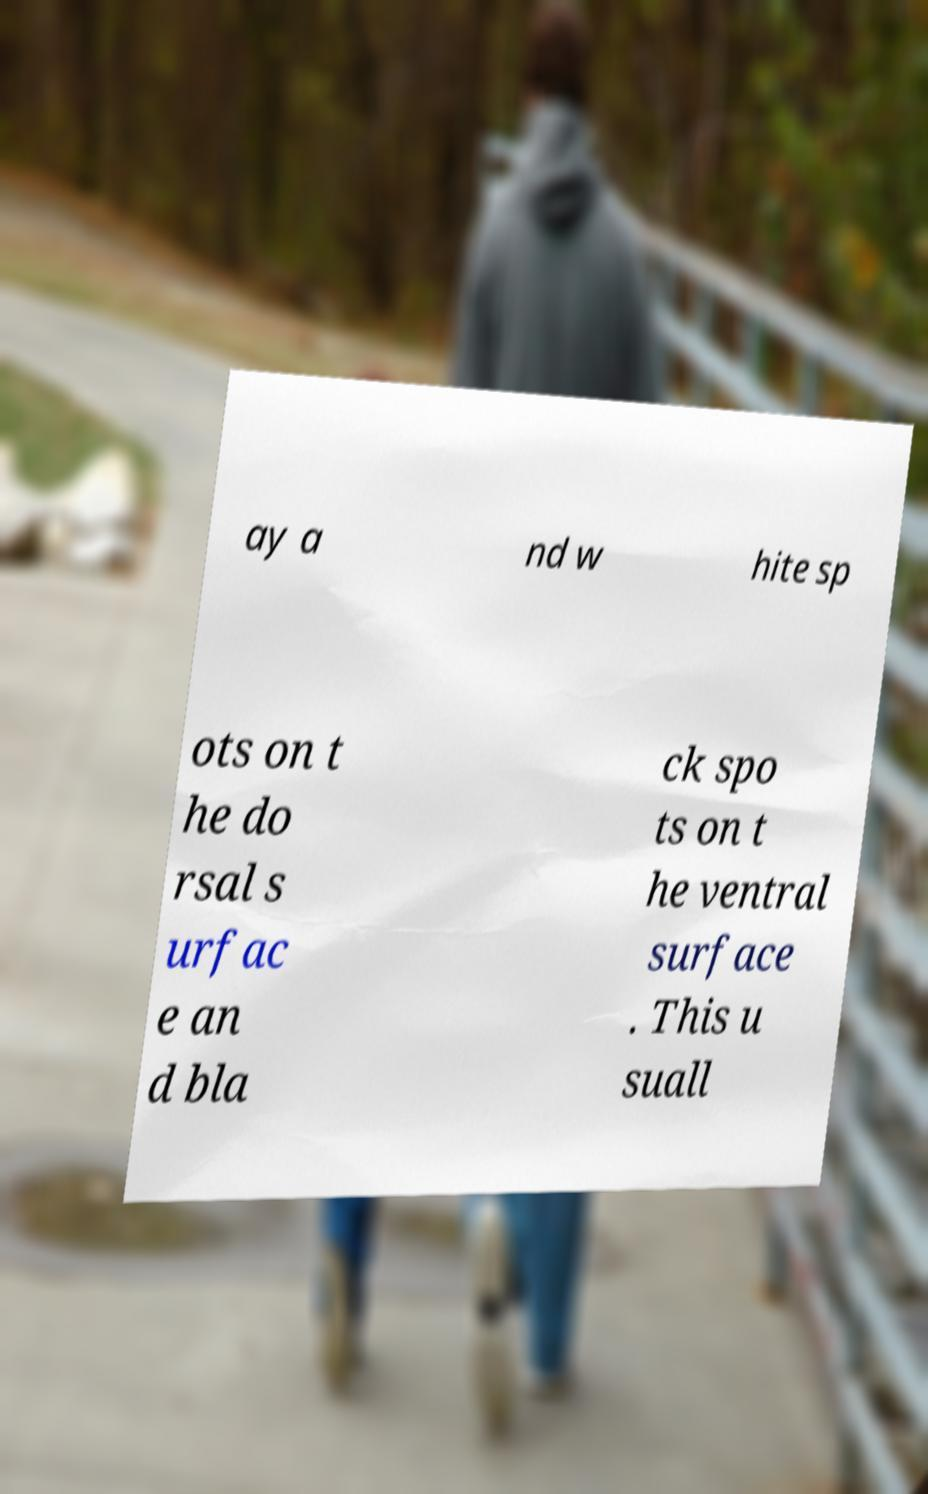Could you assist in decoding the text presented in this image and type it out clearly? ay a nd w hite sp ots on t he do rsal s urfac e an d bla ck spo ts on t he ventral surface . This u suall 